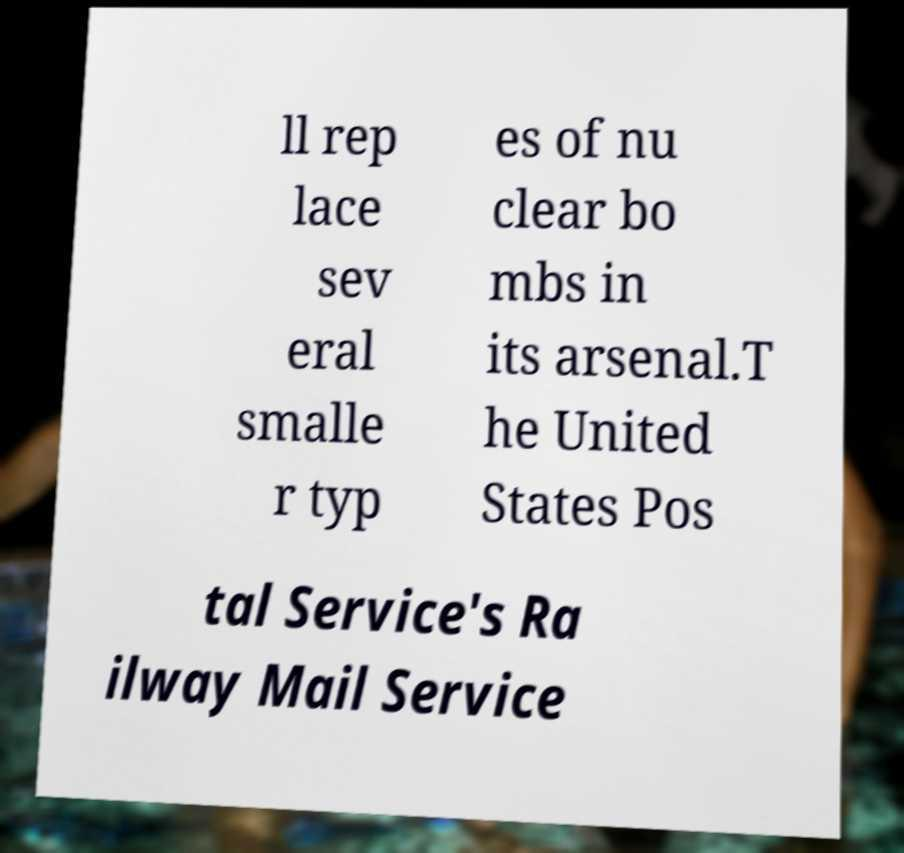Please identify and transcribe the text found in this image. ll rep lace sev eral smalle r typ es of nu clear bo mbs in its arsenal.T he United States Pos tal Service's Ra ilway Mail Service 